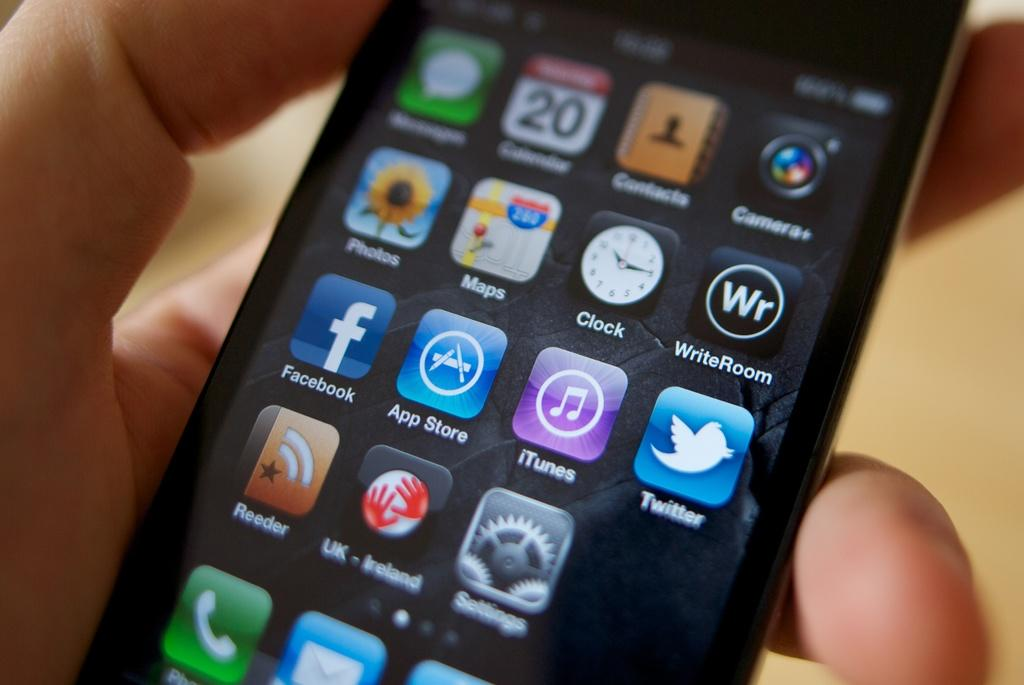<image>
Write a terse but informative summary of the picture. A person is using an iPhone with an app called WriteRoom installed. 